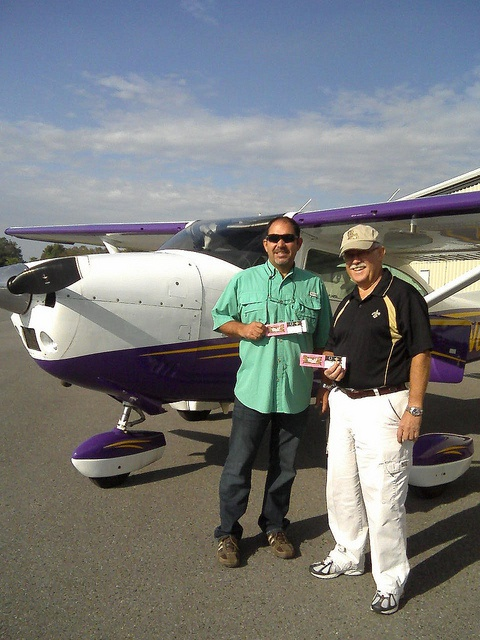Describe the objects in this image and their specific colors. I can see airplane in gray, black, darkgray, and ivory tones, people in gray, ivory, black, and tan tones, people in gray, aquamarine, black, turquoise, and teal tones, and clock in gray and darkgray tones in this image. 